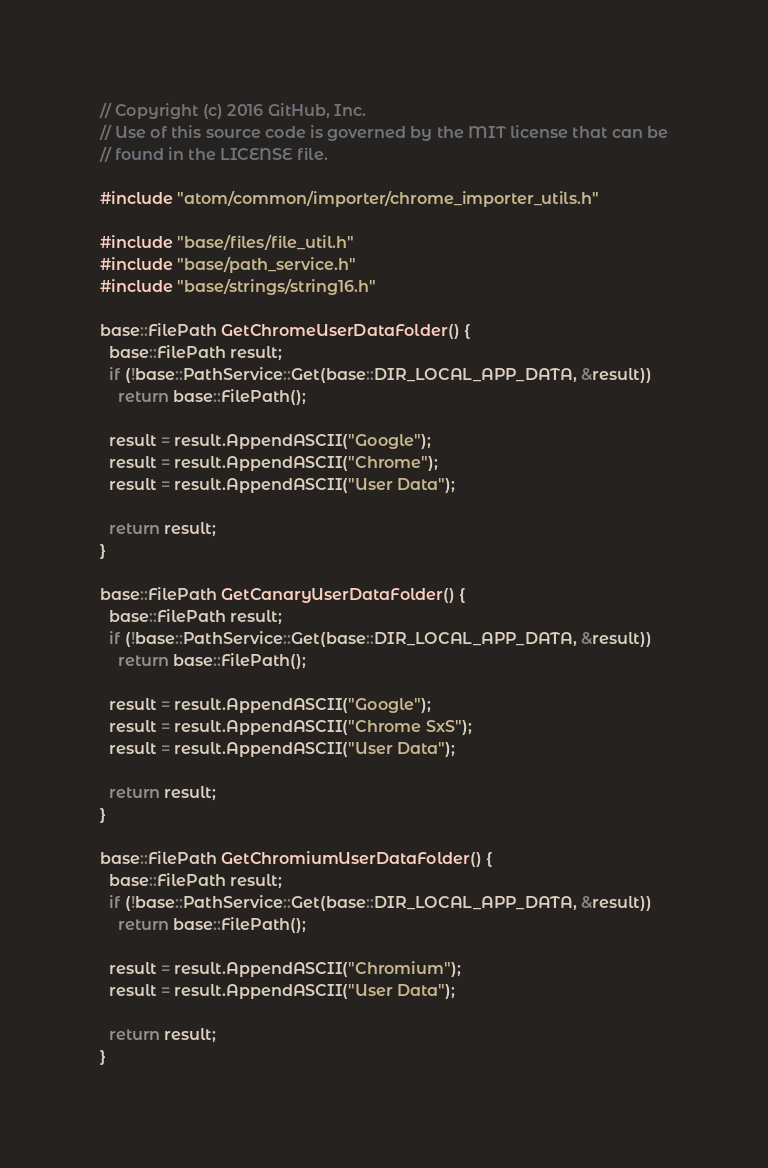<code> <loc_0><loc_0><loc_500><loc_500><_C++_>// Copyright (c) 2016 GitHub, Inc.
// Use of this source code is governed by the MIT license that can be
// found in the LICENSE file.

#include "atom/common/importer/chrome_importer_utils.h"

#include "base/files/file_util.h"
#include "base/path_service.h"
#include "base/strings/string16.h"

base::FilePath GetChromeUserDataFolder() {
  base::FilePath result;
  if (!base::PathService::Get(base::DIR_LOCAL_APP_DATA, &result))
    return base::FilePath();

  result = result.AppendASCII("Google");
  result = result.AppendASCII("Chrome");
  result = result.AppendASCII("User Data");

  return result;
}

base::FilePath GetCanaryUserDataFolder() {
  base::FilePath result;
  if (!base::PathService::Get(base::DIR_LOCAL_APP_DATA, &result))
    return base::FilePath();

  result = result.AppendASCII("Google");
  result = result.AppendASCII("Chrome SxS");
  result = result.AppendASCII("User Data");

  return result;
}

base::FilePath GetChromiumUserDataFolder() {
  base::FilePath result;
  if (!base::PathService::Get(base::DIR_LOCAL_APP_DATA, &result))
    return base::FilePath();

  result = result.AppendASCII("Chromium");
  result = result.AppendASCII("User Data");

  return result;
}
</code> 